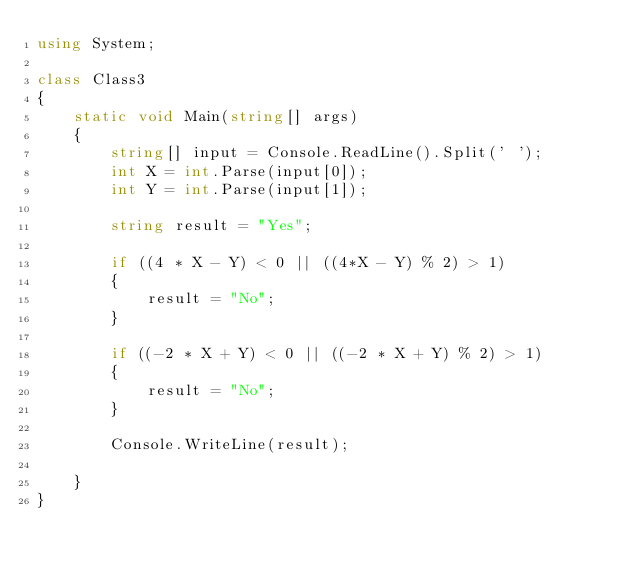Convert code to text. <code><loc_0><loc_0><loc_500><loc_500><_C#_>using System;

class Class3
{
    static void Main(string[] args)
    {
        string[] input = Console.ReadLine().Split(' ');
        int X = int.Parse(input[0]);
        int Y = int.Parse(input[1]);

        string result = "Yes";

        if ((4 * X - Y) < 0 || ((4*X - Y) % 2) > 1)
        {
            result = "No";
        }

        if ((-2 * X + Y) < 0 || ((-2 * X + Y) % 2) > 1)
        {
            result = "No";
        }

        Console.WriteLine(result);

    }
}
</code> 